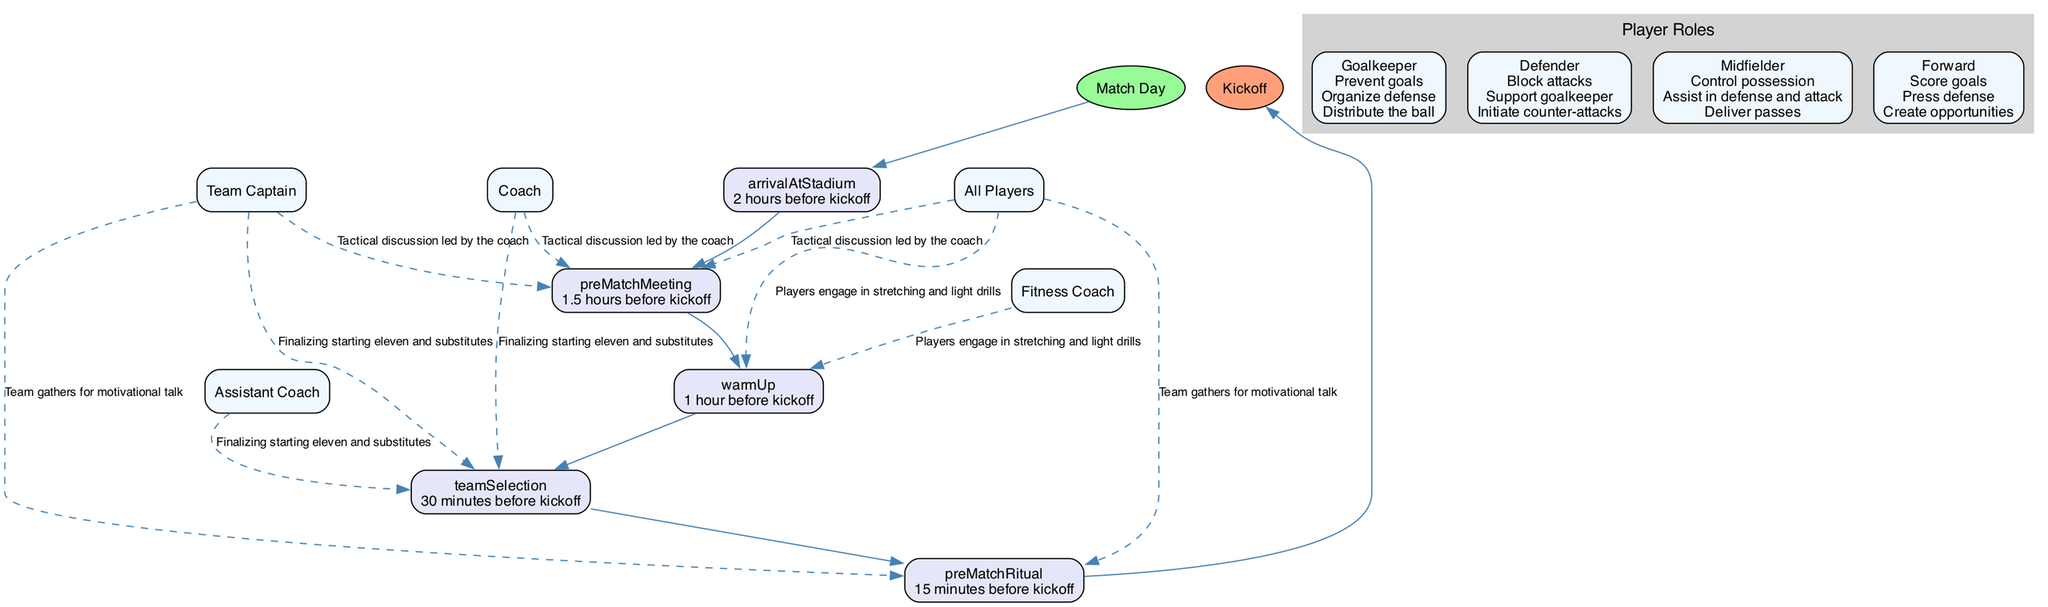What time do players arrive at the stadium? According to the diagram, players arrive at the stadium 2 hours before kickoff. This detail is specified in the 'arrivalAtStadium' section of the match day preparation activities.
Answer: 2 hours before kickoff Who leads the tactical discussion? The diagram indicates that the tactical discussion during the pre-match meeting is led by the coach. This information is included in the 'preMatchMeeting' section where the coach is listed as the leader.
Answer: Coach How many preparation steps are listed in the diagram? By counting the nodes within the match day preparation sequence, we find there are five distinct preparation steps: arrival at stadium, pre-match meeting, warm-up, team selection, and pre-match ritual.
Answer: 5 What is the activity during warm-up? The warm-up activity is described in the diagram as players engaging in stretching and light drills. This is specified in the 'warmUp' section of the preparation steps.
Answer: Players engage in stretching and light drills Which participants are involved in the finalizing of team selection? The diagram lists three participants involved in the team selection: the coach, assistant coach, and team captain. This is detailed in the 'teamSelection' section of the preparation activities.
Answer: Coach, Assistant Coach, Team Captain What color represents the preparation steps? The preparation steps in the diagram are represented with a light lavender color, as specified in the node attributes for the preparation steps within the visual representation.
Answer: Light lavender Which player role is responsible for scoring goals? According to the player roles section in the diagram, the forward is responsible for scoring goals. This specific responsibility is noted within the responsibilities for the forward.
Answer: Forward What participants gather for the motivational talk? The team captain and all players gather for the motivational talk, as indicated in the 'preMatchRitual' section of the preparation steps.
Answer: Team Captain, All Players How do defenders support the goalkeeper? The diagram highlights that defenders support the goalkeeper by blocking attacks, which is specifically mentioned as one of their responsibilities in the player roles section.
Answer: Block attacks 